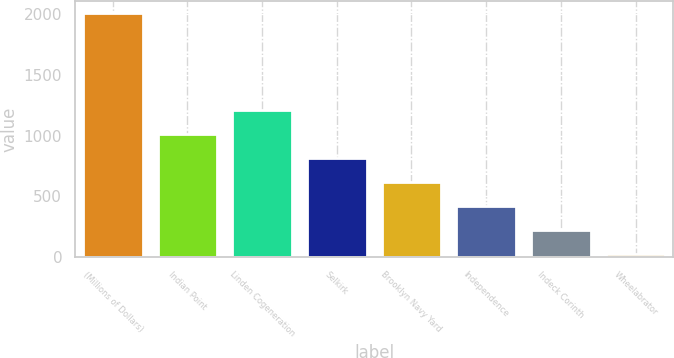Convert chart to OTSL. <chart><loc_0><loc_0><loc_500><loc_500><bar_chart><fcel>(Millions of Dollars)<fcel>Indian Point<fcel>Linden Cogeneration<fcel>Selkirk<fcel>Brooklyn Navy Yard<fcel>Independence<fcel>Indeck Corinth<fcel>Wheelabrator<nl><fcel>2006<fcel>1015.5<fcel>1213.6<fcel>817.4<fcel>619.3<fcel>421.2<fcel>223.1<fcel>25<nl></chart> 